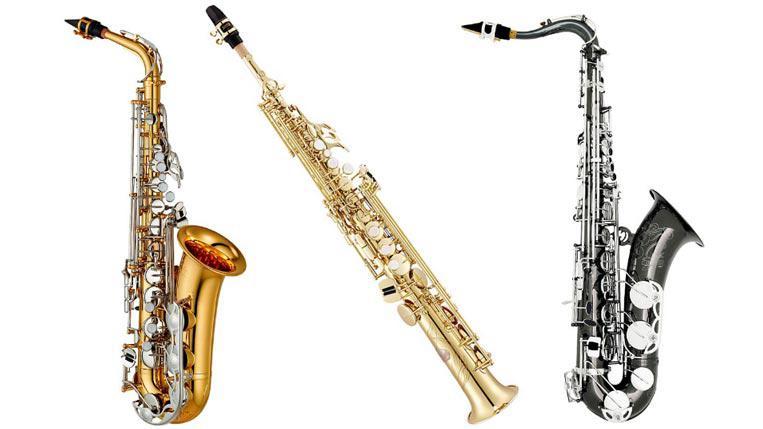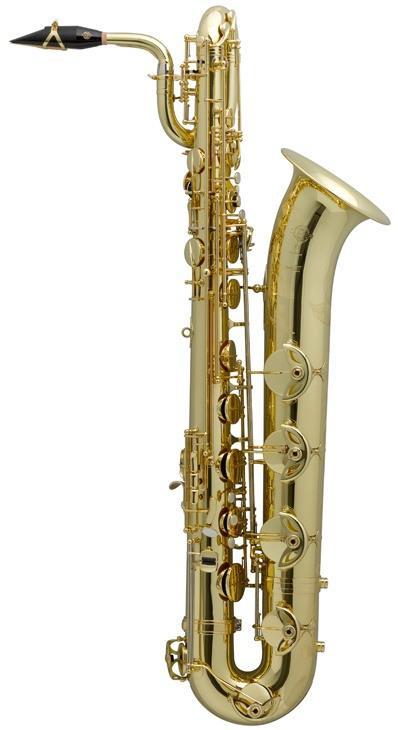The first image is the image on the left, the second image is the image on the right. Considering the images on both sides, is "There is a soprano saxophone labeled." valid? Answer yes or no. No. The first image is the image on the left, the second image is the image on the right. Examine the images to the left and right. Is the description "Neither of the images in the pair show more than three saxophones." accurate? Answer yes or no. Yes. 